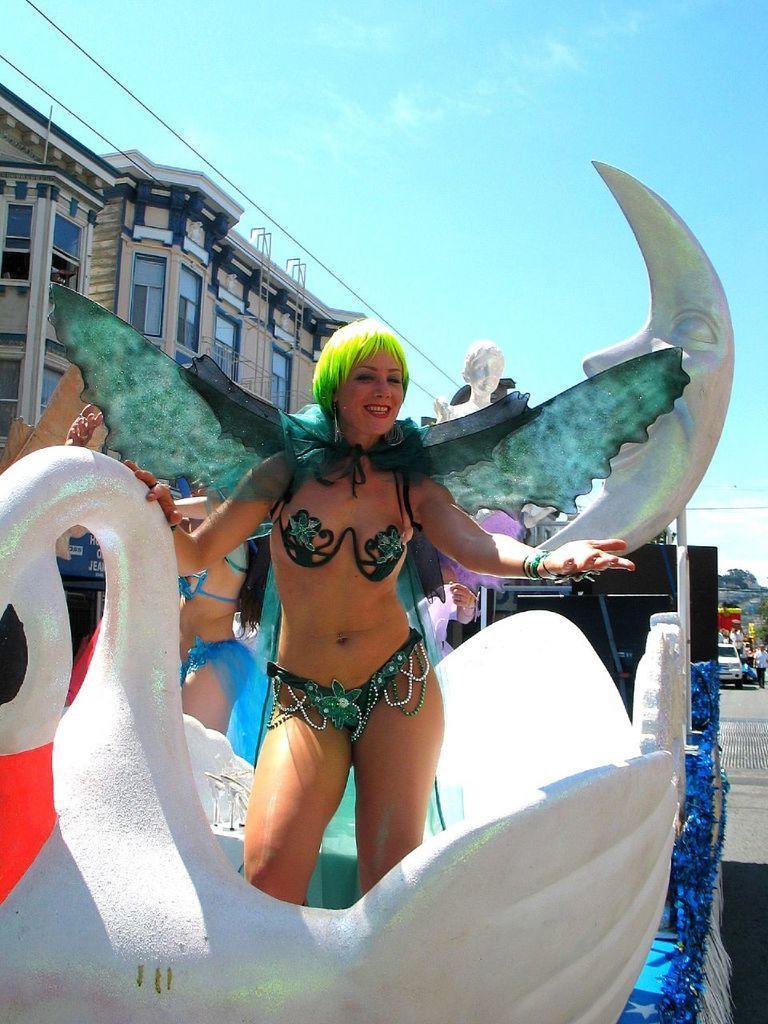Can you describe this image briefly? In the foreground I can see a woman is standing in a vehicle and a statue. In the background I can see vehicles, group of people, trees, buildings and the sky. This image is taken may be during a day on the road. 